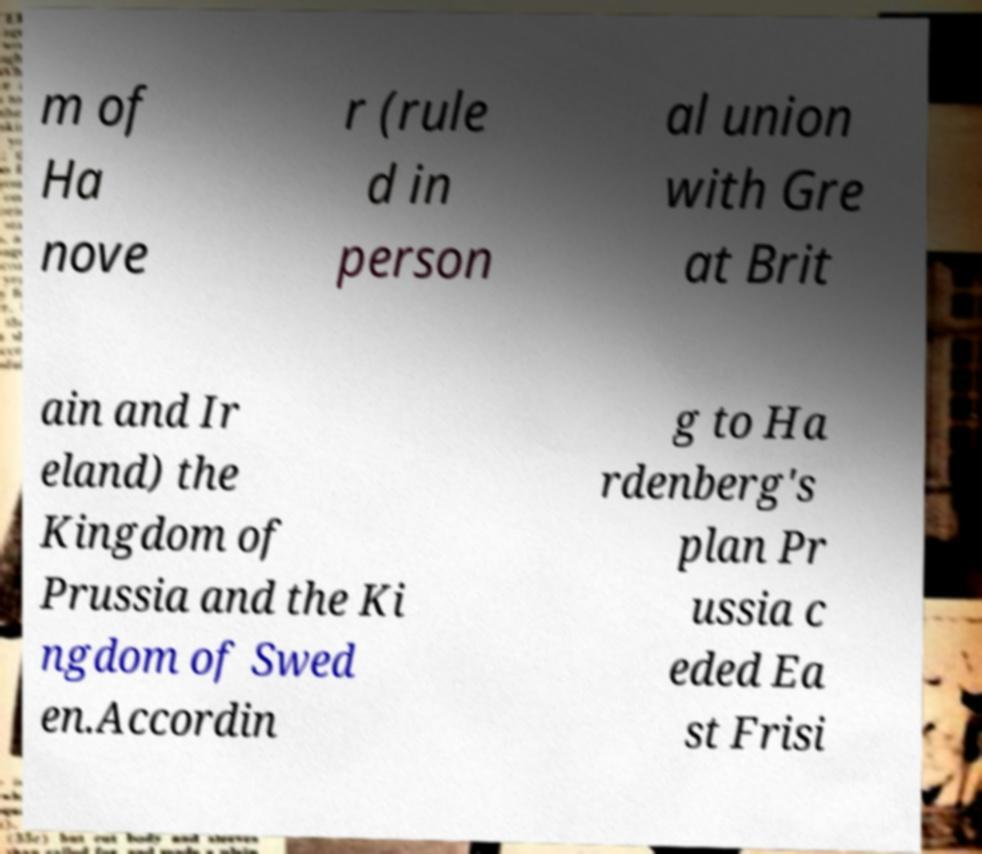Please identify and transcribe the text found in this image. m of Ha nove r (rule d in person al union with Gre at Brit ain and Ir eland) the Kingdom of Prussia and the Ki ngdom of Swed en.Accordin g to Ha rdenberg's plan Pr ussia c eded Ea st Frisi 